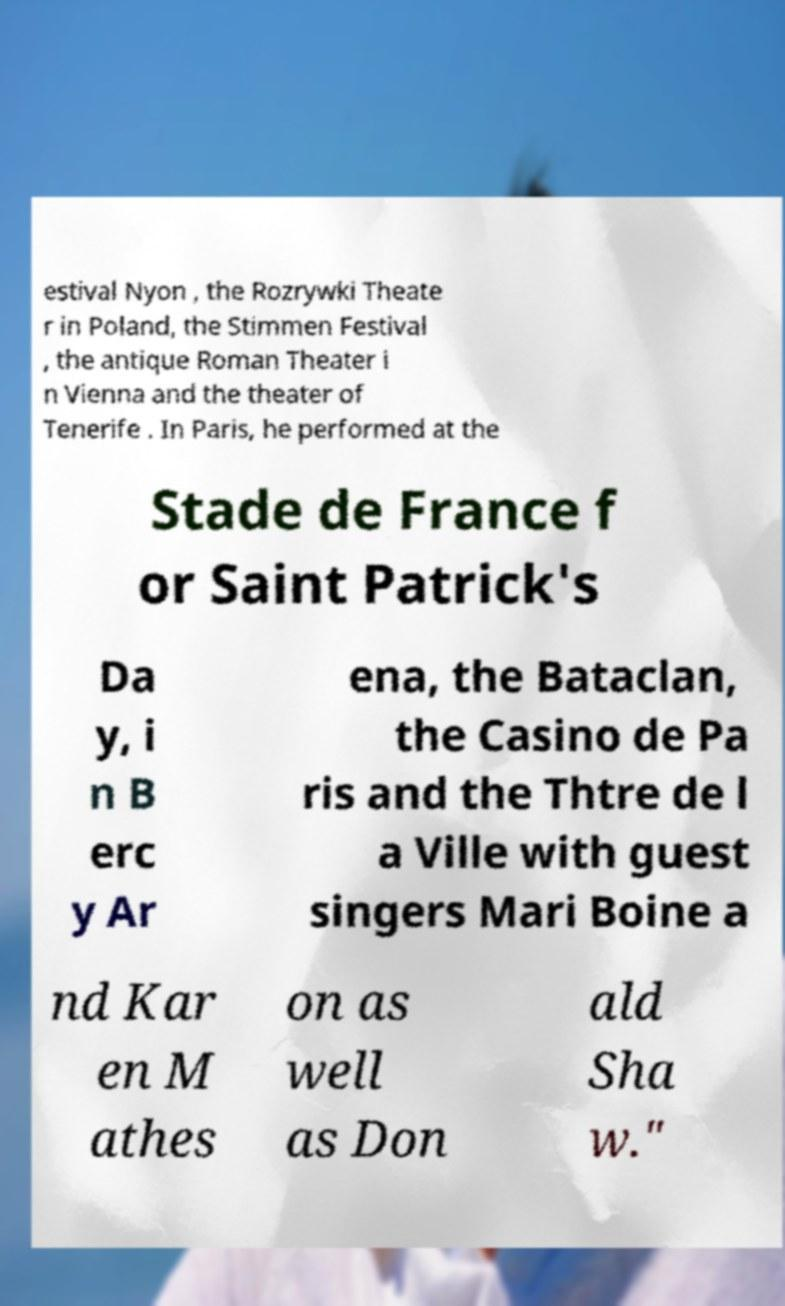I need the written content from this picture converted into text. Can you do that? estival Nyon , the Rozrywki Theate r in Poland, the Stimmen Festival , the antique Roman Theater i n Vienna and the theater of Tenerife . In Paris, he performed at the Stade de France f or Saint Patrick's Da y, i n B erc y Ar ena, the Bataclan, the Casino de Pa ris and the Thtre de l a Ville with guest singers Mari Boine a nd Kar en M athes on as well as Don ald Sha w." 